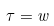<formula> <loc_0><loc_0><loc_500><loc_500>\tau = w</formula> 